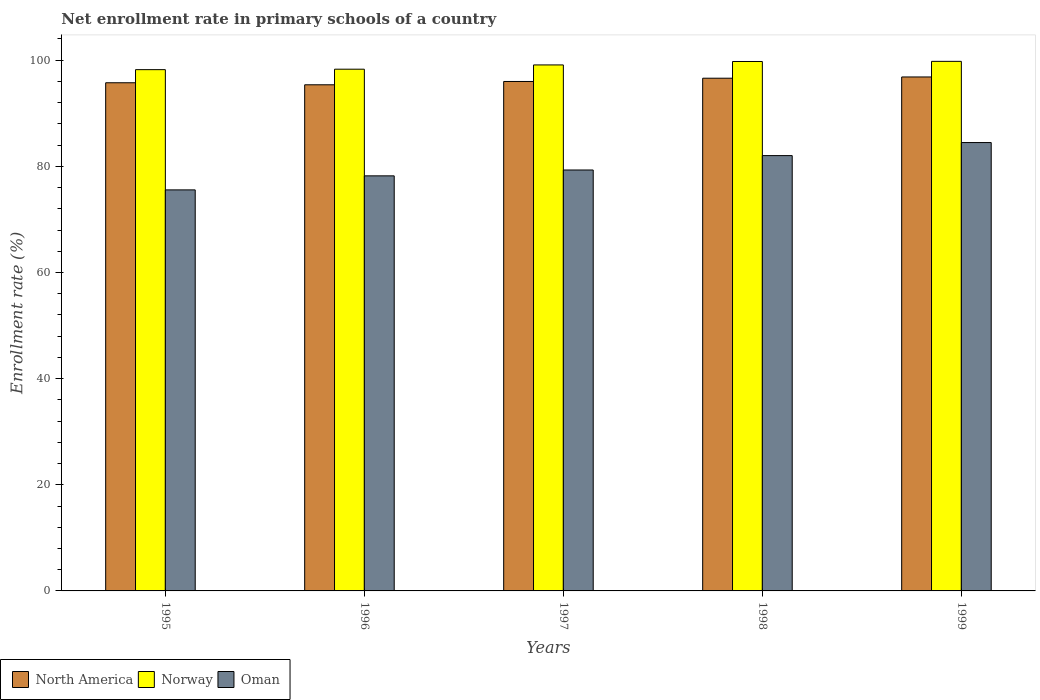How many groups of bars are there?
Your answer should be very brief. 5. Are the number of bars per tick equal to the number of legend labels?
Your response must be concise. Yes. How many bars are there on the 1st tick from the left?
Offer a very short reply. 3. What is the label of the 1st group of bars from the left?
Your answer should be very brief. 1995. In how many cases, is the number of bars for a given year not equal to the number of legend labels?
Your answer should be very brief. 0. What is the enrollment rate in primary schools in Norway in 1999?
Keep it short and to the point. 99.78. Across all years, what is the maximum enrollment rate in primary schools in Oman?
Provide a short and direct response. 84.48. Across all years, what is the minimum enrollment rate in primary schools in Norway?
Offer a very short reply. 98.21. In which year was the enrollment rate in primary schools in North America maximum?
Your response must be concise. 1999. What is the total enrollment rate in primary schools in Oman in the graph?
Your answer should be very brief. 399.57. What is the difference between the enrollment rate in primary schools in North America in 1995 and that in 1998?
Make the answer very short. -0.86. What is the difference between the enrollment rate in primary schools in Norway in 1998 and the enrollment rate in primary schools in North America in 1995?
Make the answer very short. 4.01. What is the average enrollment rate in primary schools in North America per year?
Offer a terse response. 96.11. In the year 1997, what is the difference between the enrollment rate in primary schools in Oman and enrollment rate in primary schools in North America?
Make the answer very short. -16.68. What is the ratio of the enrollment rate in primary schools in Norway in 1995 to that in 1999?
Offer a terse response. 0.98. Is the difference between the enrollment rate in primary schools in Oman in 1997 and 1999 greater than the difference between the enrollment rate in primary schools in North America in 1997 and 1999?
Your answer should be compact. No. What is the difference between the highest and the second highest enrollment rate in primary schools in North America?
Offer a terse response. 0.24. What is the difference between the highest and the lowest enrollment rate in primary schools in Norway?
Your answer should be very brief. 1.56. In how many years, is the enrollment rate in primary schools in North America greater than the average enrollment rate in primary schools in North America taken over all years?
Give a very brief answer. 2. Is the sum of the enrollment rate in primary schools in Oman in 1996 and 1997 greater than the maximum enrollment rate in primary schools in Norway across all years?
Offer a very short reply. Yes. What does the 1st bar from the right in 1997 represents?
Ensure brevity in your answer.  Oman. Does the graph contain any zero values?
Your response must be concise. No. How are the legend labels stacked?
Provide a succinct answer. Horizontal. What is the title of the graph?
Your answer should be compact. Net enrollment rate in primary schools of a country. What is the label or title of the Y-axis?
Give a very brief answer. Enrollment rate (%). What is the Enrollment rate (%) in North America in 1995?
Your answer should be compact. 95.74. What is the Enrollment rate (%) of Norway in 1995?
Your answer should be compact. 98.21. What is the Enrollment rate (%) of Oman in 1995?
Ensure brevity in your answer.  75.56. What is the Enrollment rate (%) of North America in 1996?
Provide a short and direct response. 95.36. What is the Enrollment rate (%) in Norway in 1996?
Offer a terse response. 98.3. What is the Enrollment rate (%) of Oman in 1996?
Offer a very short reply. 78.21. What is the Enrollment rate (%) of North America in 1997?
Your answer should be very brief. 95.99. What is the Enrollment rate (%) of Norway in 1997?
Provide a succinct answer. 99.1. What is the Enrollment rate (%) in Oman in 1997?
Offer a terse response. 79.31. What is the Enrollment rate (%) of North America in 1998?
Ensure brevity in your answer.  96.6. What is the Enrollment rate (%) in Norway in 1998?
Your answer should be very brief. 99.75. What is the Enrollment rate (%) in Oman in 1998?
Your answer should be compact. 82.02. What is the Enrollment rate (%) of North America in 1999?
Give a very brief answer. 96.84. What is the Enrollment rate (%) of Norway in 1999?
Provide a succinct answer. 99.78. What is the Enrollment rate (%) of Oman in 1999?
Offer a terse response. 84.48. Across all years, what is the maximum Enrollment rate (%) in North America?
Offer a very short reply. 96.84. Across all years, what is the maximum Enrollment rate (%) of Norway?
Provide a succinct answer. 99.78. Across all years, what is the maximum Enrollment rate (%) of Oman?
Your response must be concise. 84.48. Across all years, what is the minimum Enrollment rate (%) in North America?
Your answer should be very brief. 95.36. Across all years, what is the minimum Enrollment rate (%) in Norway?
Give a very brief answer. 98.21. Across all years, what is the minimum Enrollment rate (%) of Oman?
Make the answer very short. 75.56. What is the total Enrollment rate (%) in North America in the graph?
Ensure brevity in your answer.  480.53. What is the total Enrollment rate (%) of Norway in the graph?
Offer a very short reply. 495.15. What is the total Enrollment rate (%) in Oman in the graph?
Your answer should be compact. 399.57. What is the difference between the Enrollment rate (%) of North America in 1995 and that in 1996?
Give a very brief answer. 0.38. What is the difference between the Enrollment rate (%) in Norway in 1995 and that in 1996?
Provide a short and direct response. -0.09. What is the difference between the Enrollment rate (%) of Oman in 1995 and that in 1996?
Ensure brevity in your answer.  -2.64. What is the difference between the Enrollment rate (%) in North America in 1995 and that in 1997?
Your answer should be very brief. -0.24. What is the difference between the Enrollment rate (%) of Norway in 1995 and that in 1997?
Make the answer very short. -0.89. What is the difference between the Enrollment rate (%) in Oman in 1995 and that in 1997?
Your response must be concise. -3.75. What is the difference between the Enrollment rate (%) in North America in 1995 and that in 1998?
Your response must be concise. -0.86. What is the difference between the Enrollment rate (%) in Norway in 1995 and that in 1998?
Keep it short and to the point. -1.54. What is the difference between the Enrollment rate (%) of Oman in 1995 and that in 1998?
Your answer should be compact. -6.46. What is the difference between the Enrollment rate (%) in North America in 1995 and that in 1999?
Offer a terse response. -1.09. What is the difference between the Enrollment rate (%) in Norway in 1995 and that in 1999?
Your response must be concise. -1.56. What is the difference between the Enrollment rate (%) of Oman in 1995 and that in 1999?
Keep it short and to the point. -8.92. What is the difference between the Enrollment rate (%) in North America in 1996 and that in 1997?
Keep it short and to the point. -0.62. What is the difference between the Enrollment rate (%) in Norway in 1996 and that in 1997?
Provide a succinct answer. -0.8. What is the difference between the Enrollment rate (%) of Oman in 1996 and that in 1997?
Your response must be concise. -1.1. What is the difference between the Enrollment rate (%) of North America in 1996 and that in 1998?
Provide a short and direct response. -1.24. What is the difference between the Enrollment rate (%) of Norway in 1996 and that in 1998?
Offer a very short reply. -1.45. What is the difference between the Enrollment rate (%) in Oman in 1996 and that in 1998?
Keep it short and to the point. -3.81. What is the difference between the Enrollment rate (%) in North America in 1996 and that in 1999?
Provide a succinct answer. -1.48. What is the difference between the Enrollment rate (%) in Norway in 1996 and that in 1999?
Give a very brief answer. -1.48. What is the difference between the Enrollment rate (%) of Oman in 1996 and that in 1999?
Provide a succinct answer. -6.27. What is the difference between the Enrollment rate (%) in North America in 1997 and that in 1998?
Make the answer very short. -0.61. What is the difference between the Enrollment rate (%) of Norway in 1997 and that in 1998?
Offer a terse response. -0.65. What is the difference between the Enrollment rate (%) in Oman in 1997 and that in 1998?
Your answer should be very brief. -2.71. What is the difference between the Enrollment rate (%) in North America in 1997 and that in 1999?
Make the answer very short. -0.85. What is the difference between the Enrollment rate (%) of Norway in 1997 and that in 1999?
Your response must be concise. -0.67. What is the difference between the Enrollment rate (%) of Oman in 1997 and that in 1999?
Your answer should be very brief. -5.17. What is the difference between the Enrollment rate (%) in North America in 1998 and that in 1999?
Make the answer very short. -0.24. What is the difference between the Enrollment rate (%) in Norway in 1998 and that in 1999?
Offer a terse response. -0.02. What is the difference between the Enrollment rate (%) of Oman in 1998 and that in 1999?
Give a very brief answer. -2.46. What is the difference between the Enrollment rate (%) of North America in 1995 and the Enrollment rate (%) of Norway in 1996?
Your response must be concise. -2.56. What is the difference between the Enrollment rate (%) in North America in 1995 and the Enrollment rate (%) in Oman in 1996?
Keep it short and to the point. 17.54. What is the difference between the Enrollment rate (%) in Norway in 1995 and the Enrollment rate (%) in Oman in 1996?
Offer a terse response. 20.01. What is the difference between the Enrollment rate (%) in North America in 1995 and the Enrollment rate (%) in Norway in 1997?
Provide a short and direct response. -3.36. What is the difference between the Enrollment rate (%) of North America in 1995 and the Enrollment rate (%) of Oman in 1997?
Provide a short and direct response. 16.43. What is the difference between the Enrollment rate (%) of Norway in 1995 and the Enrollment rate (%) of Oman in 1997?
Your answer should be very brief. 18.9. What is the difference between the Enrollment rate (%) in North America in 1995 and the Enrollment rate (%) in Norway in 1998?
Provide a short and direct response. -4.01. What is the difference between the Enrollment rate (%) in North America in 1995 and the Enrollment rate (%) in Oman in 1998?
Your answer should be compact. 13.73. What is the difference between the Enrollment rate (%) of Norway in 1995 and the Enrollment rate (%) of Oman in 1998?
Keep it short and to the point. 16.2. What is the difference between the Enrollment rate (%) in North America in 1995 and the Enrollment rate (%) in Norway in 1999?
Ensure brevity in your answer.  -4.03. What is the difference between the Enrollment rate (%) of North America in 1995 and the Enrollment rate (%) of Oman in 1999?
Provide a succinct answer. 11.26. What is the difference between the Enrollment rate (%) of Norway in 1995 and the Enrollment rate (%) of Oman in 1999?
Provide a short and direct response. 13.73. What is the difference between the Enrollment rate (%) in North America in 1996 and the Enrollment rate (%) in Norway in 1997?
Provide a succinct answer. -3.74. What is the difference between the Enrollment rate (%) of North America in 1996 and the Enrollment rate (%) of Oman in 1997?
Ensure brevity in your answer.  16.05. What is the difference between the Enrollment rate (%) of Norway in 1996 and the Enrollment rate (%) of Oman in 1997?
Keep it short and to the point. 18.99. What is the difference between the Enrollment rate (%) of North America in 1996 and the Enrollment rate (%) of Norway in 1998?
Keep it short and to the point. -4.39. What is the difference between the Enrollment rate (%) in North America in 1996 and the Enrollment rate (%) in Oman in 1998?
Give a very brief answer. 13.34. What is the difference between the Enrollment rate (%) in Norway in 1996 and the Enrollment rate (%) in Oman in 1998?
Offer a very short reply. 16.28. What is the difference between the Enrollment rate (%) of North America in 1996 and the Enrollment rate (%) of Norway in 1999?
Your response must be concise. -4.42. What is the difference between the Enrollment rate (%) of North America in 1996 and the Enrollment rate (%) of Oman in 1999?
Your answer should be very brief. 10.88. What is the difference between the Enrollment rate (%) in Norway in 1996 and the Enrollment rate (%) in Oman in 1999?
Provide a succinct answer. 13.82. What is the difference between the Enrollment rate (%) of North America in 1997 and the Enrollment rate (%) of Norway in 1998?
Offer a terse response. -3.77. What is the difference between the Enrollment rate (%) in North America in 1997 and the Enrollment rate (%) in Oman in 1998?
Your answer should be very brief. 13.97. What is the difference between the Enrollment rate (%) of Norway in 1997 and the Enrollment rate (%) of Oman in 1998?
Your response must be concise. 17.08. What is the difference between the Enrollment rate (%) in North America in 1997 and the Enrollment rate (%) in Norway in 1999?
Offer a terse response. -3.79. What is the difference between the Enrollment rate (%) in North America in 1997 and the Enrollment rate (%) in Oman in 1999?
Provide a short and direct response. 11.51. What is the difference between the Enrollment rate (%) of Norway in 1997 and the Enrollment rate (%) of Oman in 1999?
Offer a terse response. 14.62. What is the difference between the Enrollment rate (%) in North America in 1998 and the Enrollment rate (%) in Norway in 1999?
Your answer should be compact. -3.18. What is the difference between the Enrollment rate (%) of North America in 1998 and the Enrollment rate (%) of Oman in 1999?
Your response must be concise. 12.12. What is the difference between the Enrollment rate (%) in Norway in 1998 and the Enrollment rate (%) in Oman in 1999?
Offer a terse response. 15.27. What is the average Enrollment rate (%) in North America per year?
Your answer should be very brief. 96.11. What is the average Enrollment rate (%) in Norway per year?
Offer a terse response. 99.03. What is the average Enrollment rate (%) in Oman per year?
Provide a short and direct response. 79.91. In the year 1995, what is the difference between the Enrollment rate (%) of North America and Enrollment rate (%) of Norway?
Offer a very short reply. -2.47. In the year 1995, what is the difference between the Enrollment rate (%) in North America and Enrollment rate (%) in Oman?
Your response must be concise. 20.18. In the year 1995, what is the difference between the Enrollment rate (%) of Norway and Enrollment rate (%) of Oman?
Provide a succinct answer. 22.65. In the year 1996, what is the difference between the Enrollment rate (%) in North America and Enrollment rate (%) in Norway?
Make the answer very short. -2.94. In the year 1996, what is the difference between the Enrollment rate (%) of North America and Enrollment rate (%) of Oman?
Your answer should be very brief. 17.16. In the year 1996, what is the difference between the Enrollment rate (%) in Norway and Enrollment rate (%) in Oman?
Ensure brevity in your answer.  20.09. In the year 1997, what is the difference between the Enrollment rate (%) in North America and Enrollment rate (%) in Norway?
Ensure brevity in your answer.  -3.12. In the year 1997, what is the difference between the Enrollment rate (%) in North America and Enrollment rate (%) in Oman?
Make the answer very short. 16.68. In the year 1997, what is the difference between the Enrollment rate (%) of Norway and Enrollment rate (%) of Oman?
Your response must be concise. 19.79. In the year 1998, what is the difference between the Enrollment rate (%) of North America and Enrollment rate (%) of Norway?
Your answer should be compact. -3.15. In the year 1998, what is the difference between the Enrollment rate (%) of North America and Enrollment rate (%) of Oman?
Give a very brief answer. 14.58. In the year 1998, what is the difference between the Enrollment rate (%) in Norway and Enrollment rate (%) in Oman?
Give a very brief answer. 17.73. In the year 1999, what is the difference between the Enrollment rate (%) of North America and Enrollment rate (%) of Norway?
Offer a very short reply. -2.94. In the year 1999, what is the difference between the Enrollment rate (%) in North America and Enrollment rate (%) in Oman?
Keep it short and to the point. 12.36. In the year 1999, what is the difference between the Enrollment rate (%) in Norway and Enrollment rate (%) in Oman?
Keep it short and to the point. 15.3. What is the ratio of the Enrollment rate (%) of Oman in 1995 to that in 1996?
Your answer should be compact. 0.97. What is the ratio of the Enrollment rate (%) of North America in 1995 to that in 1997?
Ensure brevity in your answer.  1. What is the ratio of the Enrollment rate (%) of Norway in 1995 to that in 1997?
Provide a short and direct response. 0.99. What is the ratio of the Enrollment rate (%) of Oman in 1995 to that in 1997?
Ensure brevity in your answer.  0.95. What is the ratio of the Enrollment rate (%) in North America in 1995 to that in 1998?
Give a very brief answer. 0.99. What is the ratio of the Enrollment rate (%) in Norway in 1995 to that in 1998?
Keep it short and to the point. 0.98. What is the ratio of the Enrollment rate (%) of Oman in 1995 to that in 1998?
Make the answer very short. 0.92. What is the ratio of the Enrollment rate (%) in North America in 1995 to that in 1999?
Provide a short and direct response. 0.99. What is the ratio of the Enrollment rate (%) of Norway in 1995 to that in 1999?
Provide a short and direct response. 0.98. What is the ratio of the Enrollment rate (%) in Oman in 1995 to that in 1999?
Make the answer very short. 0.89. What is the ratio of the Enrollment rate (%) of North America in 1996 to that in 1997?
Offer a very short reply. 0.99. What is the ratio of the Enrollment rate (%) in Oman in 1996 to that in 1997?
Make the answer very short. 0.99. What is the ratio of the Enrollment rate (%) of North America in 1996 to that in 1998?
Ensure brevity in your answer.  0.99. What is the ratio of the Enrollment rate (%) in Norway in 1996 to that in 1998?
Provide a short and direct response. 0.99. What is the ratio of the Enrollment rate (%) of Oman in 1996 to that in 1998?
Provide a short and direct response. 0.95. What is the ratio of the Enrollment rate (%) of North America in 1996 to that in 1999?
Keep it short and to the point. 0.98. What is the ratio of the Enrollment rate (%) in Norway in 1996 to that in 1999?
Keep it short and to the point. 0.99. What is the ratio of the Enrollment rate (%) of Oman in 1996 to that in 1999?
Keep it short and to the point. 0.93. What is the ratio of the Enrollment rate (%) in North America in 1997 to that in 1998?
Make the answer very short. 0.99. What is the ratio of the Enrollment rate (%) in Norway in 1997 to that in 1998?
Make the answer very short. 0.99. What is the ratio of the Enrollment rate (%) in North America in 1997 to that in 1999?
Your answer should be very brief. 0.99. What is the ratio of the Enrollment rate (%) of Norway in 1997 to that in 1999?
Your answer should be compact. 0.99. What is the ratio of the Enrollment rate (%) of Oman in 1997 to that in 1999?
Ensure brevity in your answer.  0.94. What is the ratio of the Enrollment rate (%) of Oman in 1998 to that in 1999?
Make the answer very short. 0.97. What is the difference between the highest and the second highest Enrollment rate (%) of North America?
Give a very brief answer. 0.24. What is the difference between the highest and the second highest Enrollment rate (%) of Norway?
Your response must be concise. 0.02. What is the difference between the highest and the second highest Enrollment rate (%) in Oman?
Keep it short and to the point. 2.46. What is the difference between the highest and the lowest Enrollment rate (%) of North America?
Provide a short and direct response. 1.48. What is the difference between the highest and the lowest Enrollment rate (%) of Norway?
Ensure brevity in your answer.  1.56. What is the difference between the highest and the lowest Enrollment rate (%) of Oman?
Your answer should be compact. 8.92. 